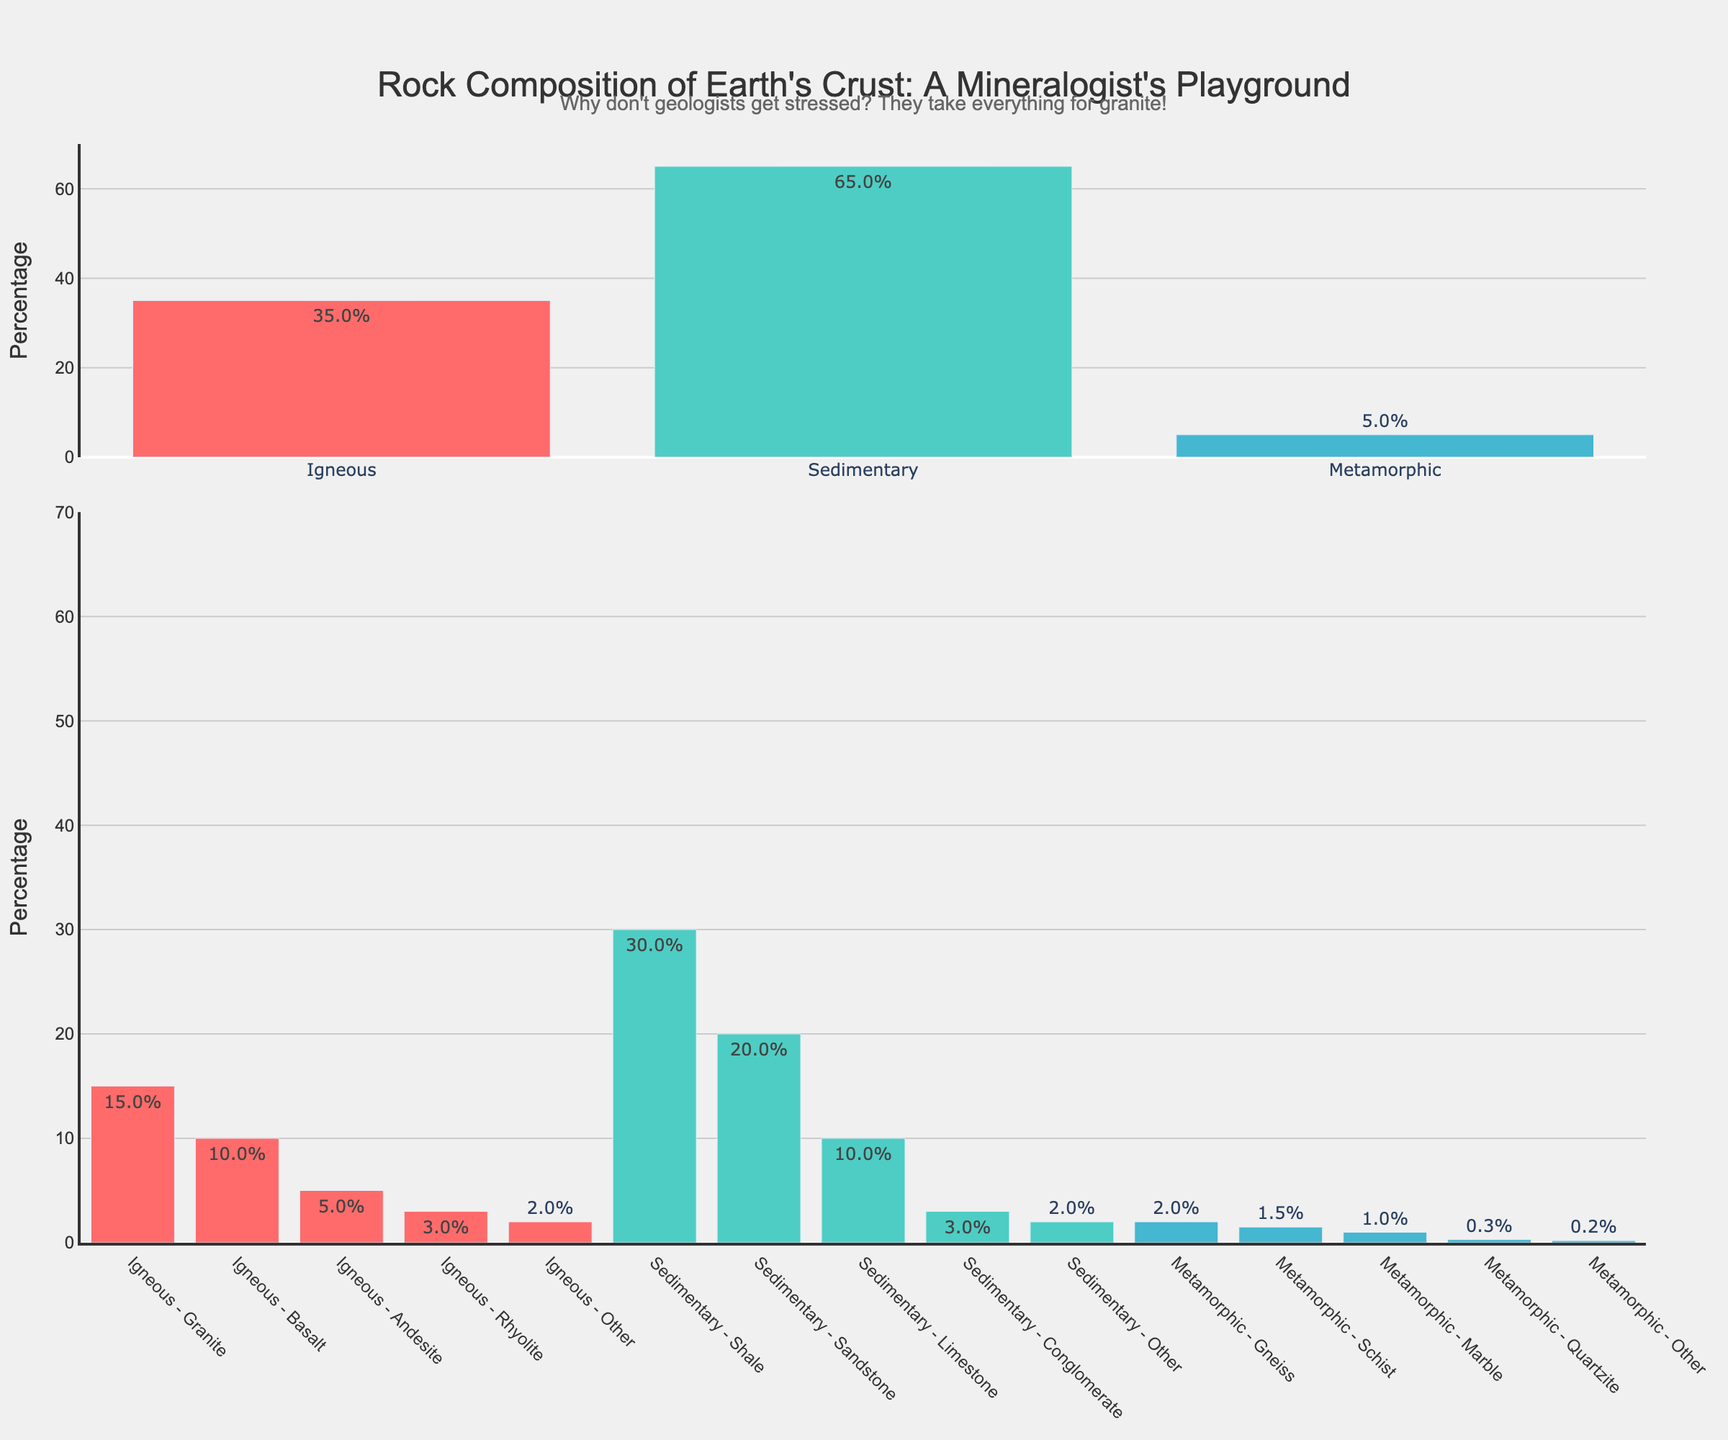What is the percentage of igneous rock type in Earth's crust? The first bar in the main categories shows the percentage of igneous rock type. The bar is represented by the first red bar from the left. The percentage is indicated by its label.
Answer: 35% What is the difference in percentage between sedimentary and metamorphic rock types? The second bar in the main categories represents sedimentary at 65%, and the third bar represents metamorphic at 5%. Subtracting the percentage of metamorphic from sedimentary gives the difference: 65% - 5% = 60%.
Answer: 60% What's the combined percentage of Granite and Basalt subcategories within igneous rocks? In the subcategories section, Granite is 15% and Basalt is 10%. Adding these two percentages together: 15% + 10% = 25%.
Answer: 25% Which subcategory has a higher percentage, Sandstone in sedimentary or Marble in metamorphic? In the subcategories of sedimentary rocks, Sandstone is 20%. For metamorphic rocks, Marble is 1%. Comparing 20% and 1%, Sandstone has a higher percentage.
Answer: Sandstone What is the aggregate percentage of all subcategories that fall under sedimentary rocks? The subcategories under sedimentary are Shale (30%), Sandstone (20%), Limestone (10%), Conglomerate (3%), and Other (2%). Adding them together: 30% + 20% + 10% + 3% + 2% = 65%.
Answer: 65% What is the percentage difference between the Granite subcategory and the Gneiss subcategory? Granite under igneous rocks is 15% and Gneiss under metamorphic rocks is 2%. The difference is 15% - 2% = 13%.
Answer: 13% Which subcategory in metamorphic rocks has the smallest percentage and what is it? In the metamorphic rock subcategories, Quartzite has 0.3% and Other has 0.2%. Other has the smallest percentage which is 0.2%.
Answer: 0.2% What is the total percentage of Metamorphic Rock types when all its subcategories are added? The subcategories for metamorphic rocks are Gneiss (2%), Schist (1.5%), Marble (1%), Quartzite (0.3%), and Other (0.2%). Adding them: 2% + 1.5% + 1% + 0.3% + 0.2% = 5%.
Answer: 5% Which rock type is represented by the color green in the main categories? In the main categories, the sedimentary rock bar is colored green.
Answer: Sedimentary How much more percentage does Shale have compared to Granite? Shale has 30% in the sedimentary subcategories, and Granite has 15% in the igneous subcategories. The difference is 30% - 15% = 15%.
Answer: 15% 